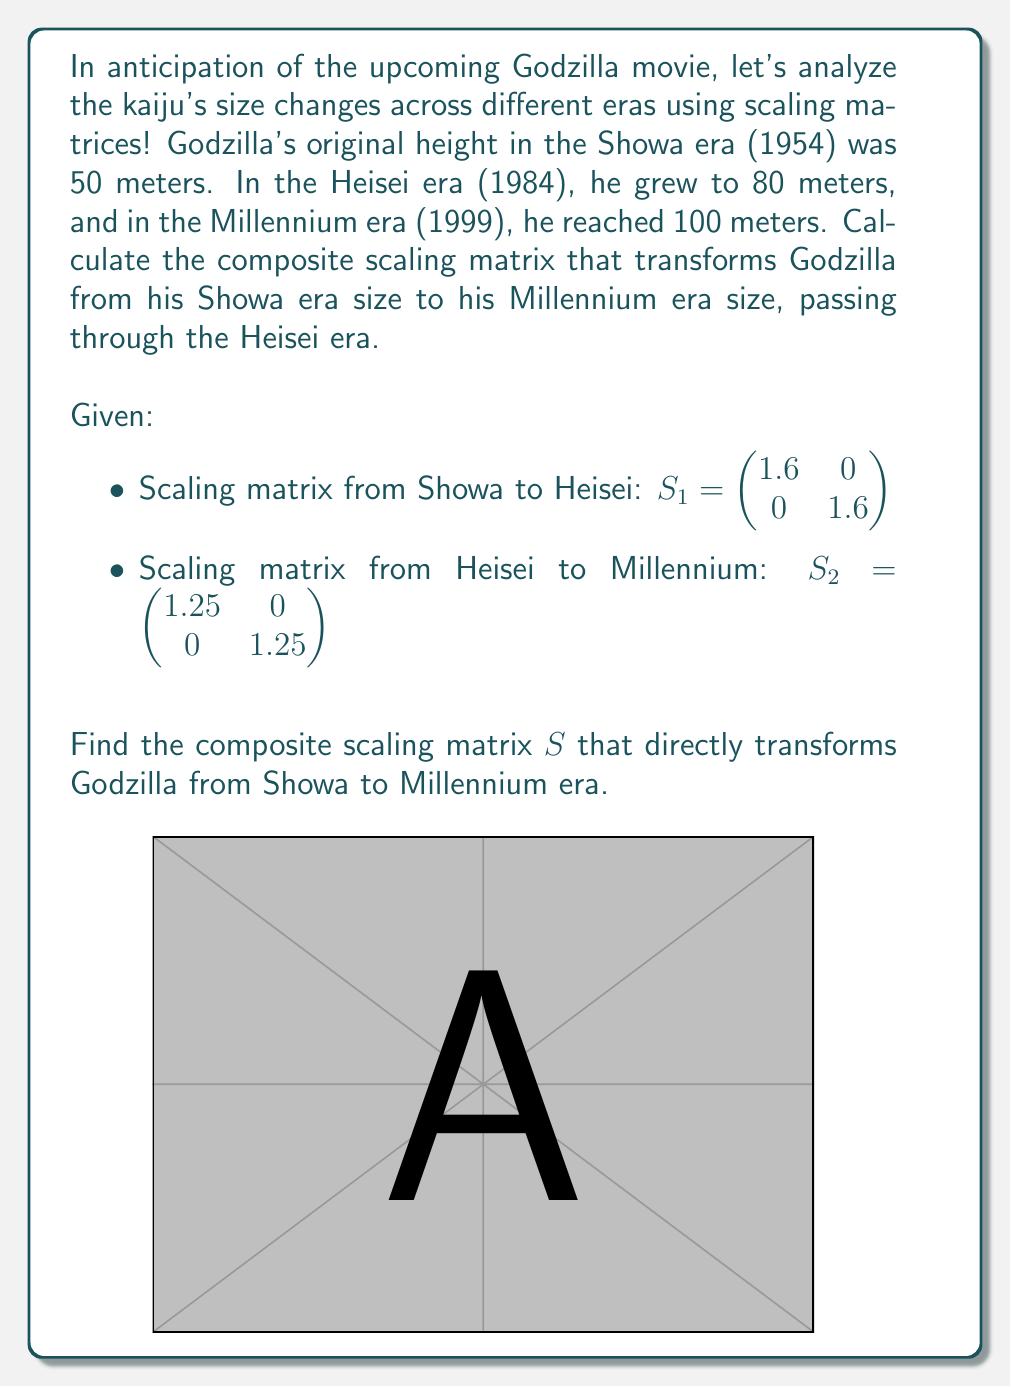Give your solution to this math problem. To find the composite scaling matrix, we need to multiply the two given scaling matrices in the correct order. The order matters because matrix multiplication is not commutative.

Step 1: Set up the matrix multiplication
We want to apply $S_1$ first (Showa to Heisei) and then $S_2$ (Heisei to Millennium). So, we multiply $S_2$ by $S_1$:

$$S = S_2 \cdot S_1$$

Step 2: Perform the matrix multiplication
$$S = \begin{pmatrix} 1.25 & 0 \\ 0 & 1.25 \end{pmatrix} \cdot \begin{pmatrix} 1.6 & 0 \\ 0 & 1.6 \end{pmatrix}$$

$$S = \begin{pmatrix} (1.25 \cdot 1.6) & (1.25 \cdot 0) \\ (0 \cdot 1.6) & (1.25 \cdot 1.6) \end{pmatrix}$$

Step 3: Calculate the resulting matrix
$$S = \begin{pmatrix} 2 & 0 \\ 0 & 2 \end{pmatrix}$$

Step 4: Verify the result
We can check our answer by applying this scaling matrix to Godzilla's original height:

$$\begin{pmatrix} 2 & 0 \\ 0 & 2 \end{pmatrix} \cdot \begin{pmatrix} 50 \\ 50 \end{pmatrix} = \begin{pmatrix} 100 \\ 100 \end{pmatrix}$$

This correctly transforms Godzilla from 50 meters (Showa) to 100 meters (Millennium).
Answer: $$S = \begin{pmatrix} 2 & 0 \\ 0 & 2 \end{pmatrix}$$ 